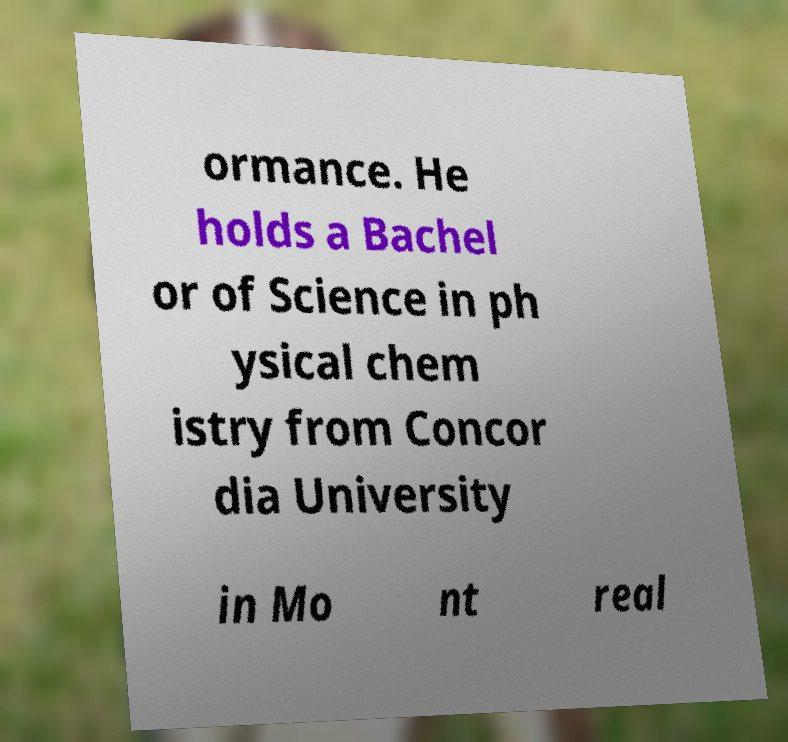Please read and relay the text visible in this image. What does it say? ormance. He holds a Bachel or of Science in ph ysical chem istry from Concor dia University in Mo nt real 